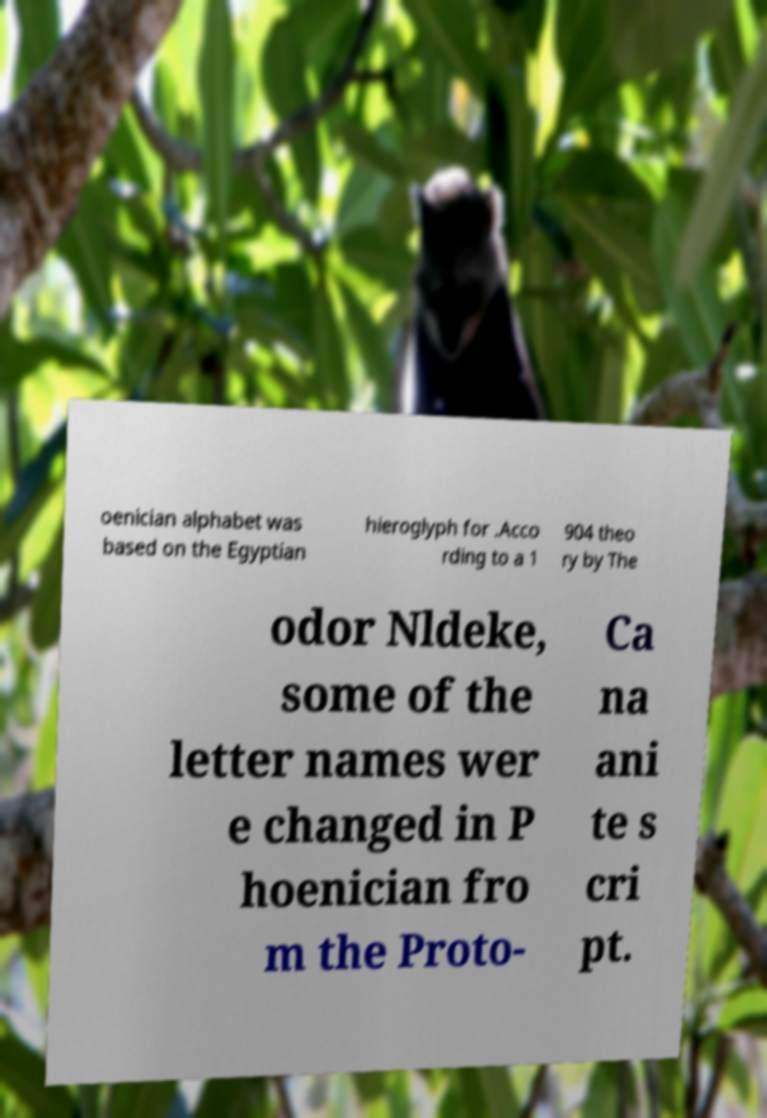What messages or text are displayed in this image? I need them in a readable, typed format. oenician alphabet was based on the Egyptian hieroglyph for .Acco rding to a 1 904 theo ry by The odor Nldeke, some of the letter names wer e changed in P hoenician fro m the Proto- Ca na ani te s cri pt. 